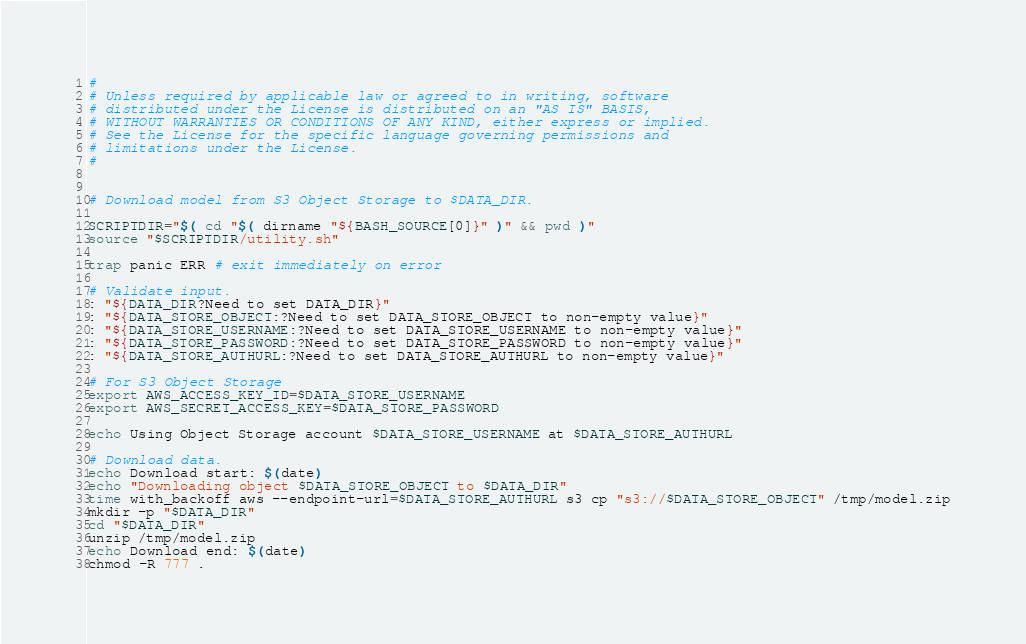<code> <loc_0><loc_0><loc_500><loc_500><_Bash_>#
# Unless required by applicable law or agreed to in writing, software
# distributed under the License is distributed on an "AS IS" BASIS,
# WITHOUT WARRANTIES OR CONDITIONS OF ANY KIND, either express or implied.
# See the License for the specific language governing permissions and
# limitations under the License.
#


# Download model from S3 Object Storage to $DATA_DIR.

SCRIPTDIR="$( cd "$( dirname "${BASH_SOURCE[0]}" )" && pwd )"
source "$SCRIPTDIR/utility.sh"

trap panic ERR # exit immediately on error

# Validate input.
: "${DATA_DIR?Need to set DATA_DIR}"
: "${DATA_STORE_OBJECT:?Need to set DATA_STORE_OBJECT to non-empty value}"
: "${DATA_STORE_USERNAME:?Need to set DATA_STORE_USERNAME to non-empty value}"
: "${DATA_STORE_PASSWORD:?Need to set DATA_STORE_PASSWORD to non-empty value}"
: "${DATA_STORE_AUTHURL:?Need to set DATA_STORE_AUTHURL to non-empty value}"

# For S3 Object Storage
export AWS_ACCESS_KEY_ID=$DATA_STORE_USERNAME
export AWS_SECRET_ACCESS_KEY=$DATA_STORE_PASSWORD

echo Using Object Storage account $DATA_STORE_USERNAME at $DATA_STORE_AUTHURL

# Download data.
echo Download start: $(date)
echo "Downloading object $DATA_STORE_OBJECT to $DATA_DIR"
time with_backoff aws --endpoint-url=$DATA_STORE_AUTHURL s3 cp "s3://$DATA_STORE_OBJECT" /tmp/model.zip
mkdir -p "$DATA_DIR"
cd "$DATA_DIR"
unzip /tmp/model.zip
echo Download end: $(date)
chmod -R 777 .
</code> 